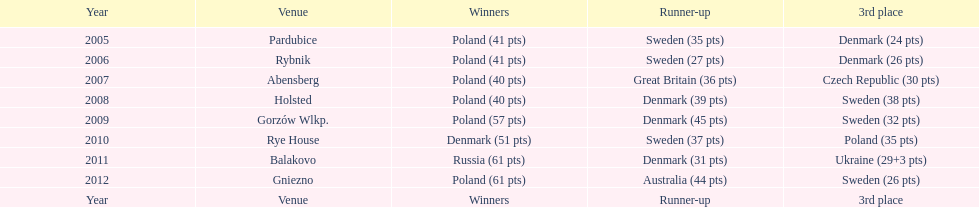When was the final year the 3rd place contestant concluded with fewer than 25 points? 2005. 